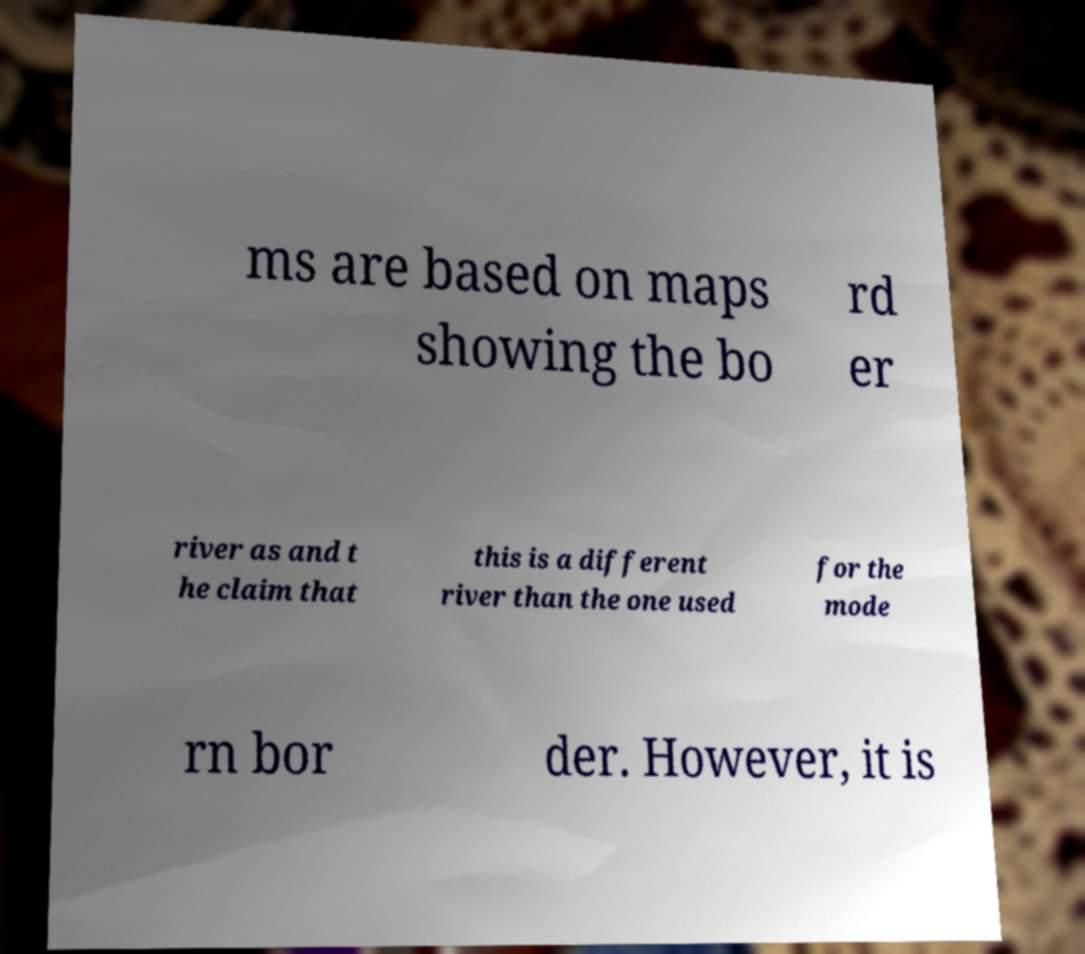Please identify and transcribe the text found in this image. ms are based on maps showing the bo rd er river as and t he claim that this is a different river than the one used for the mode rn bor der. However, it is 